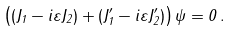Convert formula to latex. <formula><loc_0><loc_0><loc_500><loc_500>\left ( ( J _ { 1 } - i \varepsilon J _ { 2 } ) + ( J ^ { \prime } _ { 1 } - i \varepsilon J ^ { \prime } _ { 2 } ) \right ) \psi = 0 \, .</formula> 